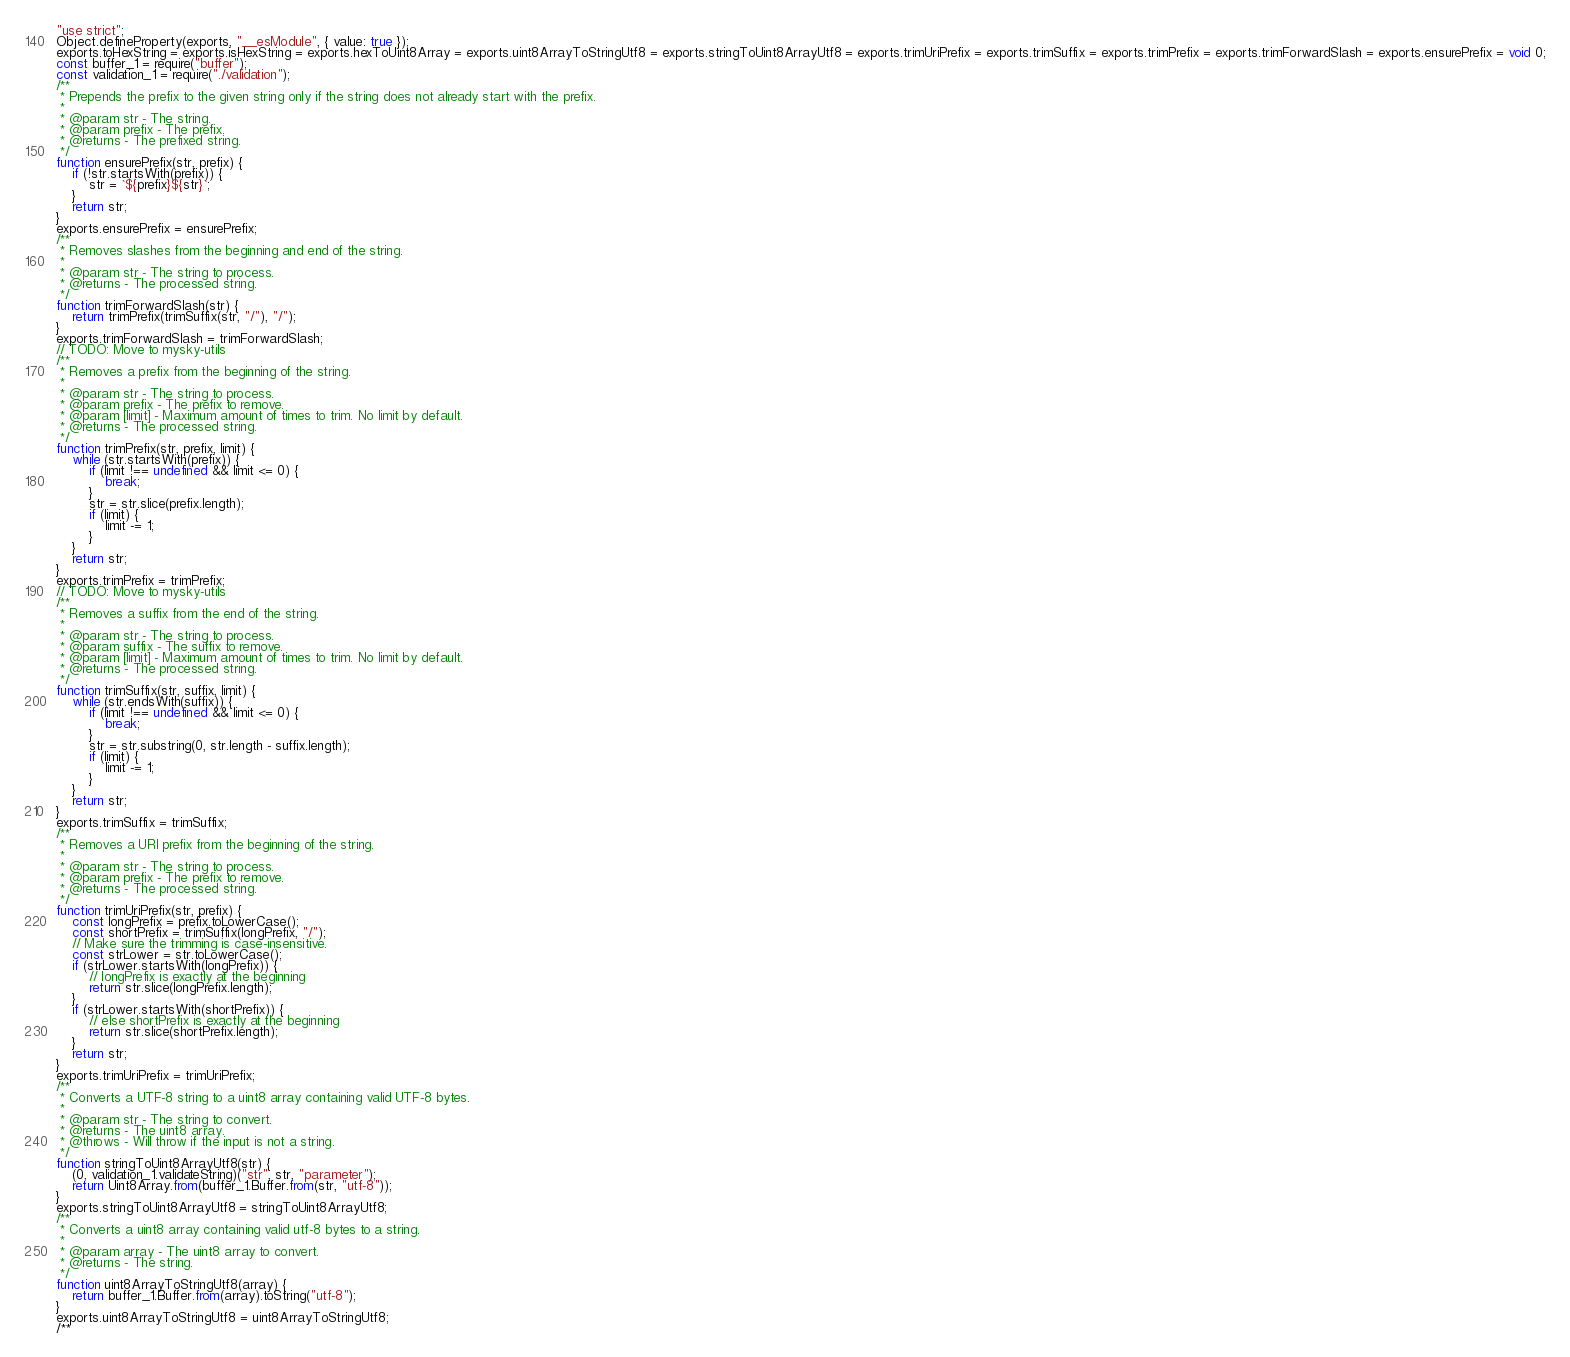<code> <loc_0><loc_0><loc_500><loc_500><_JavaScript_>"use strict";
Object.defineProperty(exports, "__esModule", { value: true });
exports.toHexString = exports.isHexString = exports.hexToUint8Array = exports.uint8ArrayToStringUtf8 = exports.stringToUint8ArrayUtf8 = exports.trimUriPrefix = exports.trimSuffix = exports.trimPrefix = exports.trimForwardSlash = exports.ensurePrefix = void 0;
const buffer_1 = require("buffer");
const validation_1 = require("./validation");
/**
 * Prepends the prefix to the given string only if the string does not already start with the prefix.
 *
 * @param str - The string.
 * @param prefix - The prefix.
 * @returns - The prefixed string.
 */
function ensurePrefix(str, prefix) {
    if (!str.startsWith(prefix)) {
        str = `${prefix}${str}`;
    }
    return str;
}
exports.ensurePrefix = ensurePrefix;
/**
 * Removes slashes from the beginning and end of the string.
 *
 * @param str - The string to process.
 * @returns - The processed string.
 */
function trimForwardSlash(str) {
    return trimPrefix(trimSuffix(str, "/"), "/");
}
exports.trimForwardSlash = trimForwardSlash;
// TODO: Move to mysky-utils
/**
 * Removes a prefix from the beginning of the string.
 *
 * @param str - The string to process.
 * @param prefix - The prefix to remove.
 * @param [limit] - Maximum amount of times to trim. No limit by default.
 * @returns - The processed string.
 */
function trimPrefix(str, prefix, limit) {
    while (str.startsWith(prefix)) {
        if (limit !== undefined && limit <= 0) {
            break;
        }
        str = str.slice(prefix.length);
        if (limit) {
            limit -= 1;
        }
    }
    return str;
}
exports.trimPrefix = trimPrefix;
// TODO: Move to mysky-utils
/**
 * Removes a suffix from the end of the string.
 *
 * @param str - The string to process.
 * @param suffix - The suffix to remove.
 * @param [limit] - Maximum amount of times to trim. No limit by default.
 * @returns - The processed string.
 */
function trimSuffix(str, suffix, limit) {
    while (str.endsWith(suffix)) {
        if (limit !== undefined && limit <= 0) {
            break;
        }
        str = str.substring(0, str.length - suffix.length);
        if (limit) {
            limit -= 1;
        }
    }
    return str;
}
exports.trimSuffix = trimSuffix;
/**
 * Removes a URI prefix from the beginning of the string.
 *
 * @param str - The string to process.
 * @param prefix - The prefix to remove.
 * @returns - The processed string.
 */
function trimUriPrefix(str, prefix) {
    const longPrefix = prefix.toLowerCase();
    const shortPrefix = trimSuffix(longPrefix, "/");
    // Make sure the trimming is case-insensitive.
    const strLower = str.toLowerCase();
    if (strLower.startsWith(longPrefix)) {
        // longPrefix is exactly at the beginning
        return str.slice(longPrefix.length);
    }
    if (strLower.startsWith(shortPrefix)) {
        // else shortPrefix is exactly at the beginning
        return str.slice(shortPrefix.length);
    }
    return str;
}
exports.trimUriPrefix = trimUriPrefix;
/**
 * Converts a UTF-8 string to a uint8 array containing valid UTF-8 bytes.
 *
 * @param str - The string to convert.
 * @returns - The uint8 array.
 * @throws - Will throw if the input is not a string.
 */
function stringToUint8ArrayUtf8(str) {
    (0, validation_1.validateString)("str", str, "parameter");
    return Uint8Array.from(buffer_1.Buffer.from(str, "utf-8"));
}
exports.stringToUint8ArrayUtf8 = stringToUint8ArrayUtf8;
/**
 * Converts a uint8 array containing valid utf-8 bytes to a string.
 *
 * @param array - The uint8 array to convert.
 * @returns - The string.
 */
function uint8ArrayToStringUtf8(array) {
    return buffer_1.Buffer.from(array).toString("utf-8");
}
exports.uint8ArrayToStringUtf8 = uint8ArrayToStringUtf8;
/**</code> 